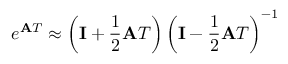<formula> <loc_0><loc_0><loc_500><loc_500>e ^ { A T } \approx \left ( I + { \frac { 1 } { 2 } } A T \right ) \left ( I - { \frac { 1 } { 2 } } A T \right ) ^ { - 1 }</formula> 